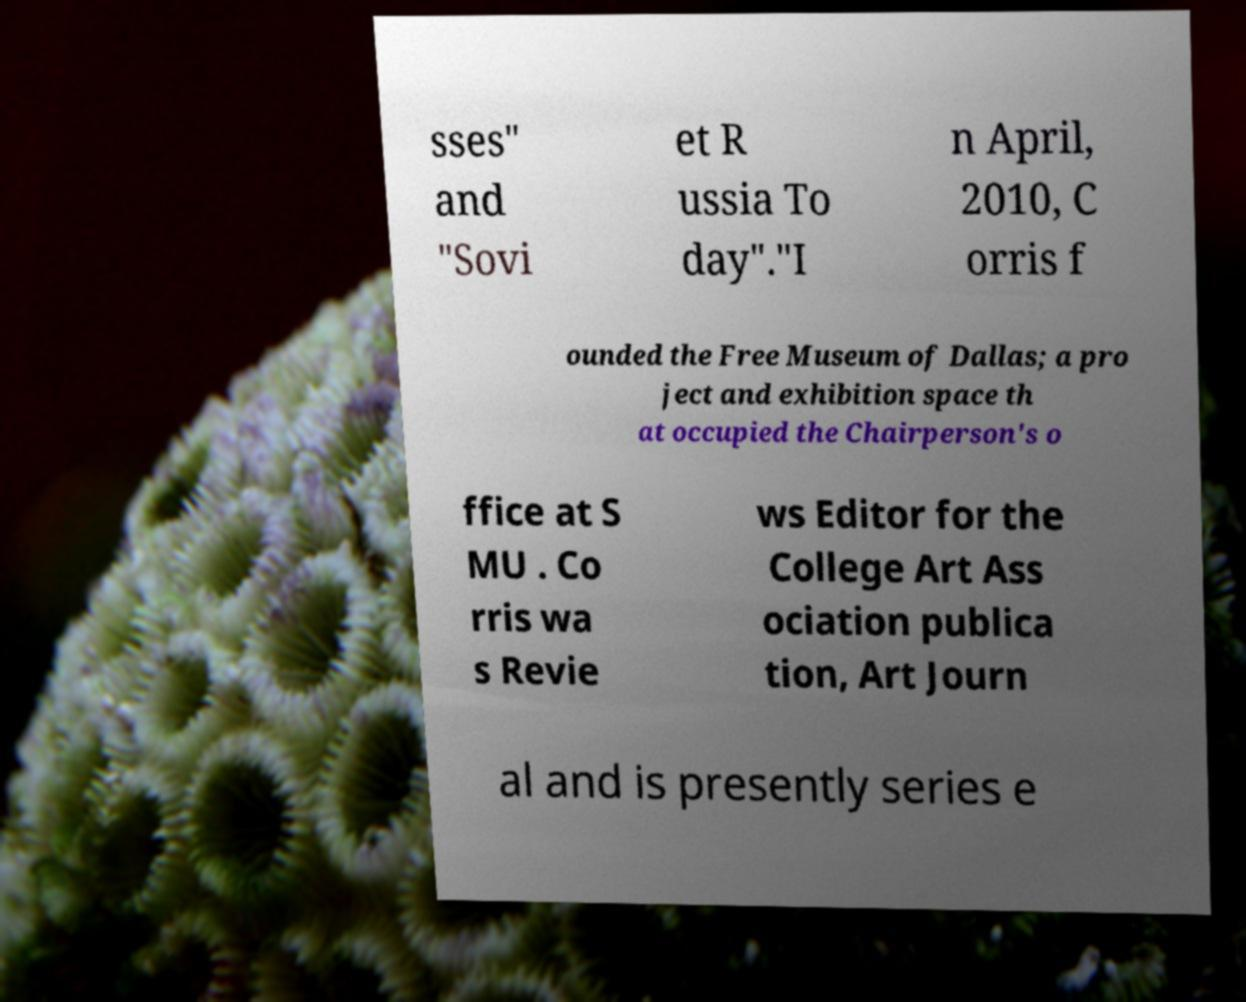Could you assist in decoding the text presented in this image and type it out clearly? sses" and "Sovi et R ussia To day"."I n April, 2010, C orris f ounded the Free Museum of Dallas; a pro ject and exhibition space th at occupied the Chairperson's o ffice at S MU . Co rris wa s Revie ws Editor for the College Art Ass ociation publica tion, Art Journ al and is presently series e 